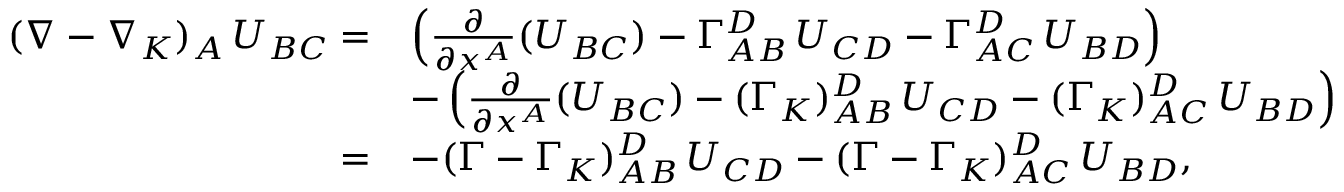<formula> <loc_0><loc_0><loc_500><loc_500>\begin{array} { r l } { ( \nabla - \nabla _ { K } ) _ { A } \, U _ { B C } = } & { \left ( \frac { \partial } { { \partial } x ^ { A } } ( U _ { B C } ) - \Gamma _ { A B } ^ { D } \, U _ { C D } - \Gamma _ { A C } ^ { D } \, U _ { B D } \right ) } \\ & { - \left ( \frac { \partial } { { \partial } x ^ { A } } ( U _ { B C } ) - ( \Gamma _ { K } ) _ { A B } ^ { D } \, U _ { C D } - ( \Gamma _ { K } ) _ { A C } ^ { D } \, U _ { B D } \right ) } \\ { = } & { - ( \Gamma - \Gamma _ { K } ) _ { A B } ^ { D } \, U _ { C D } - ( \Gamma - \Gamma _ { K } ) _ { A C } ^ { D } \, U _ { B D } , } \end{array}</formula> 